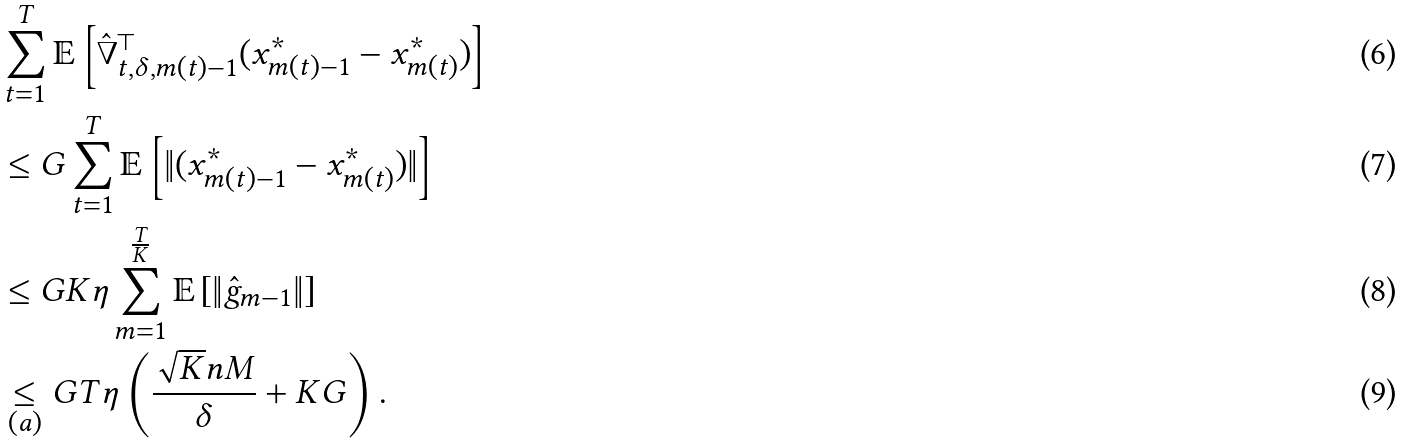<formula> <loc_0><loc_0><loc_500><loc_500>& \sum _ { t = 1 } ^ { T } \mathbb { E } \left [ \hat { \nabla } _ { t , \delta , m ( t ) - 1 } ^ { \top } ( x _ { m ( t ) - 1 } ^ { * } - x _ { m ( t ) } ^ { * } ) \right ] \\ & \leq G \sum _ { t = 1 } ^ { T } \mathbb { E } \left [ \| ( x _ { m ( t ) - 1 } ^ { * } - x _ { m ( t ) } ^ { * } ) \| \right ] \\ & \leq G K \eta \sum _ { m = 1 } ^ { \frac { T } { K } } \mathbb { E } \left [ \| \hat { g } _ { m - 1 } \| \right ] \\ & \underset { ( a ) } { \leq } G T \eta \left ( \frac { \sqrt { K } n M } { \delta } + K G \right ) .</formula> 